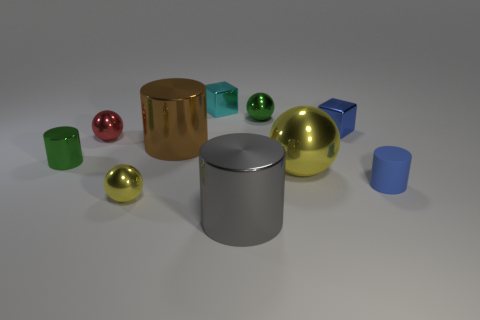Is there any other thing that has the same material as the blue cylinder?
Offer a terse response. No. There is a tiny green object to the left of the small red thing; what shape is it?
Give a very brief answer. Cylinder. What number of other objects are there of the same material as the large yellow thing?
Keep it short and to the point. 8. What is the cyan cube made of?
Your answer should be compact. Metal. What number of large things are green cylinders or gray metal cylinders?
Provide a short and direct response. 1. There is a small red metal ball; what number of balls are behind it?
Make the answer very short. 1. Is there a shiny sphere of the same color as the matte object?
Keep it short and to the point. No. There is a yellow thing that is the same size as the cyan shiny block; what shape is it?
Ensure brevity in your answer.  Sphere. What number of yellow things are metallic spheres or big cylinders?
Your answer should be very brief. 2. What number of matte cylinders have the same size as the red metal thing?
Offer a very short reply. 1. 